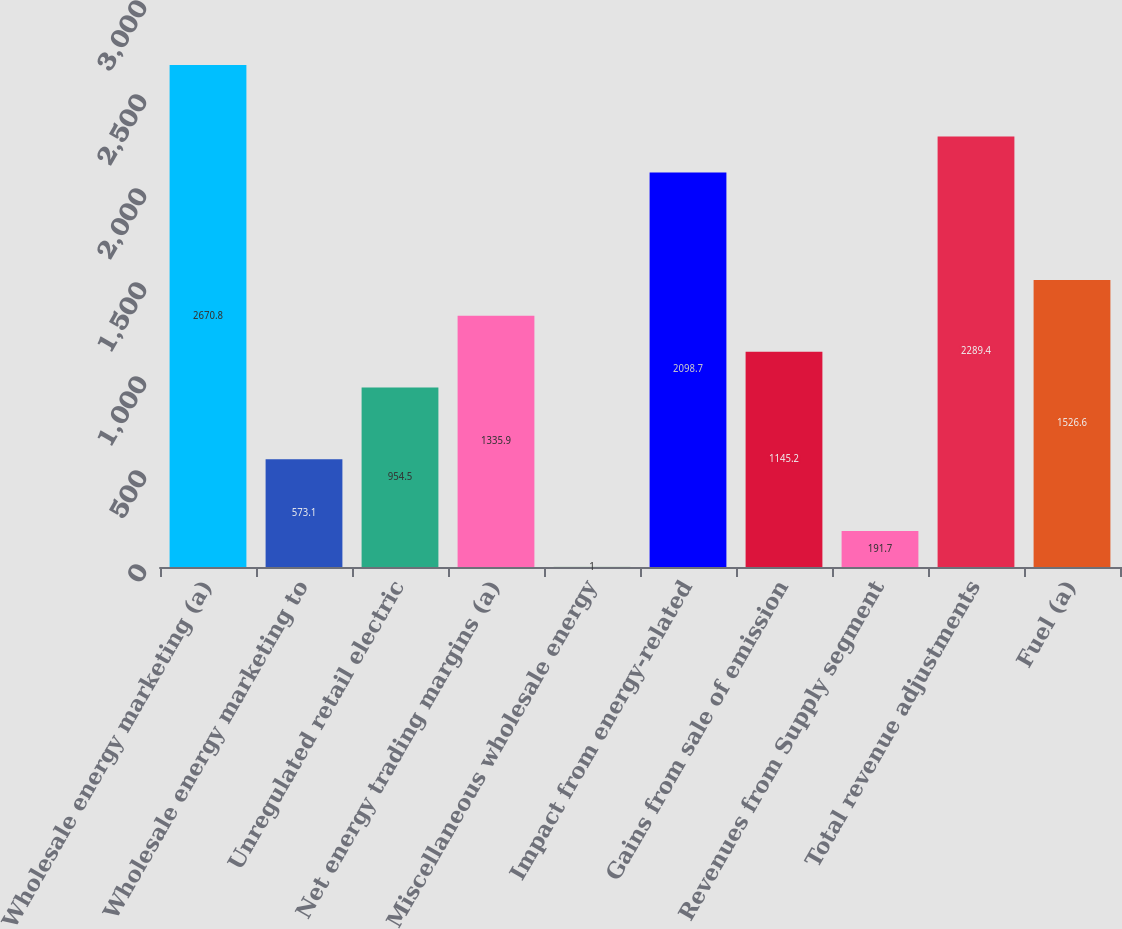<chart> <loc_0><loc_0><loc_500><loc_500><bar_chart><fcel>Wholesale energy marketing (a)<fcel>Wholesale energy marketing to<fcel>Unregulated retail electric<fcel>Net energy trading margins (a)<fcel>Miscellaneous wholesale energy<fcel>Impact from energy-related<fcel>Gains from sale of emission<fcel>Revenues from Supply segment<fcel>Total revenue adjustments<fcel>Fuel (a)<nl><fcel>2670.8<fcel>573.1<fcel>954.5<fcel>1335.9<fcel>1<fcel>2098.7<fcel>1145.2<fcel>191.7<fcel>2289.4<fcel>1526.6<nl></chart> 